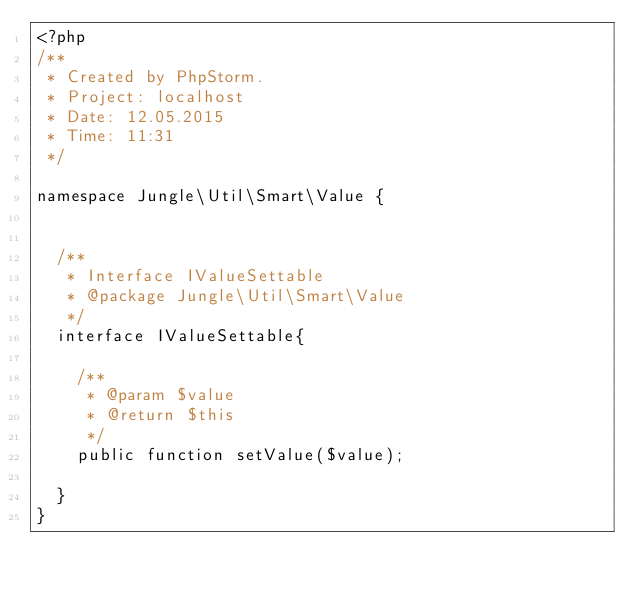Convert code to text. <code><loc_0><loc_0><loc_500><loc_500><_PHP_><?php
/**
 * Created by PhpStorm.
 * Project: localhost
 * Date: 12.05.2015
 * Time: 11:31
 */

namespace Jungle\Util\Smart\Value {


	/**
	 * Interface IValueSettable
	 * @package Jungle\Util\Smart\Value
	 */
	interface IValueSettable{

		/**
		 * @param $value
		 * @return $this
		 */
		public function setValue($value);

	}
}</code> 